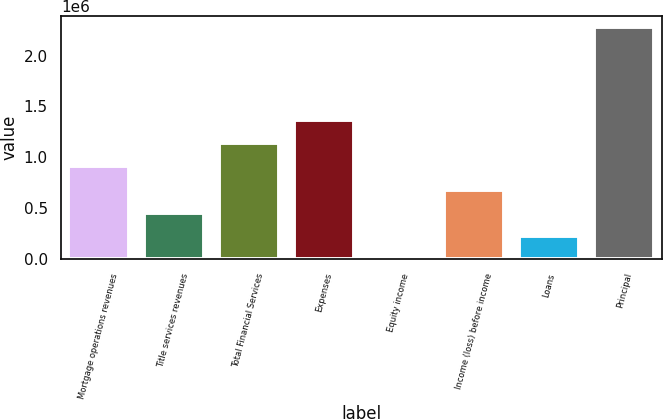<chart> <loc_0><loc_0><loc_500><loc_500><bar_chart><fcel>Mortgage operations revenues<fcel>Title services revenues<fcel>Total Financial Services<fcel>Expenses<fcel>Equity income<fcel>Income (loss) before income<fcel>Loans<fcel>Principal<nl><fcel>910410<fcel>455213<fcel>1.13801e+06<fcel>1.36561e+06<fcel>16<fcel>682811<fcel>227614<fcel>2.276e+06<nl></chart> 